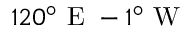<formula> <loc_0><loc_0><loc_500><loc_500>1 2 0 ^ { \circ } E - 1 ^ { \circ } W</formula> 